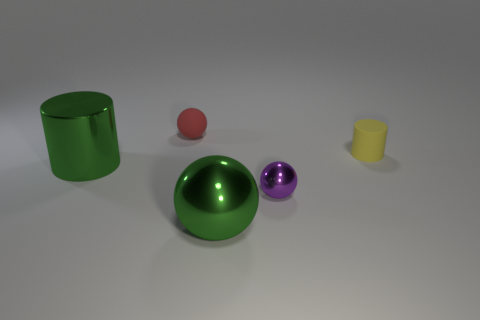Add 5 matte spheres. How many objects exist? 10 Subtract all balls. How many objects are left? 2 Add 5 tiny yellow rubber things. How many tiny yellow rubber things are left? 6 Add 3 purple balls. How many purple balls exist? 4 Subtract 1 green spheres. How many objects are left? 4 Subtract all balls. Subtract all big cyan rubber cylinders. How many objects are left? 2 